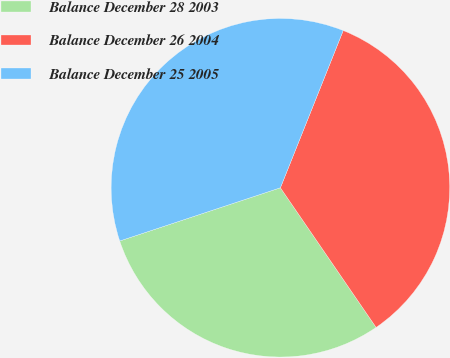Convert chart. <chart><loc_0><loc_0><loc_500><loc_500><pie_chart><fcel>Balance December 28 2003<fcel>Balance December 26 2004<fcel>Balance December 25 2005<nl><fcel>29.47%<fcel>34.39%<fcel>36.14%<nl></chart> 